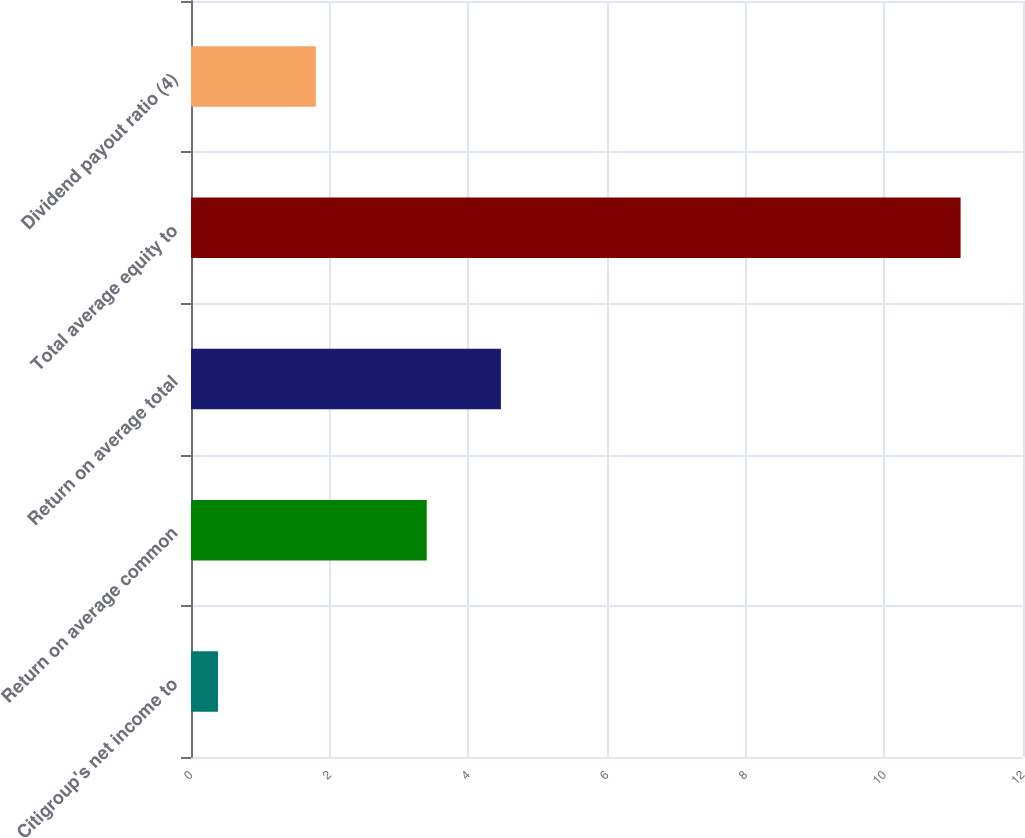Convert chart. <chart><loc_0><loc_0><loc_500><loc_500><bar_chart><fcel>Citigroup's net income to<fcel>Return on average common<fcel>Return on average total<fcel>Total average equity to<fcel>Dividend payout ratio (4)<nl><fcel>0.39<fcel>3.4<fcel>4.47<fcel>11.1<fcel>1.8<nl></chart> 